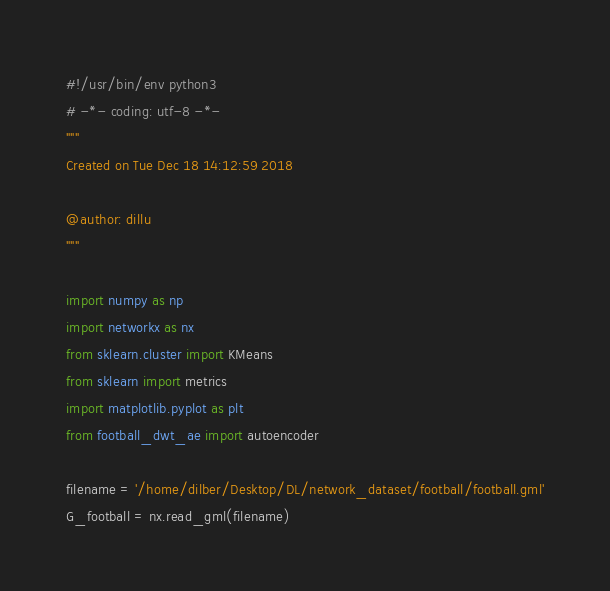Convert code to text. <code><loc_0><loc_0><loc_500><loc_500><_Python_>#!/usr/bin/env python3
# -*- coding: utf-8 -*-
"""
Created on Tue Dec 18 14:12:59 2018

@author: dillu
"""

import numpy as np
import networkx as nx
from sklearn.cluster import KMeans
from sklearn import metrics
import matplotlib.pyplot as plt
from football_dwt_ae import autoencoder

filename = '/home/dilber/Desktop/DL/network_dataset/football/football.gml'
G_football = nx.read_gml(filename)</code> 